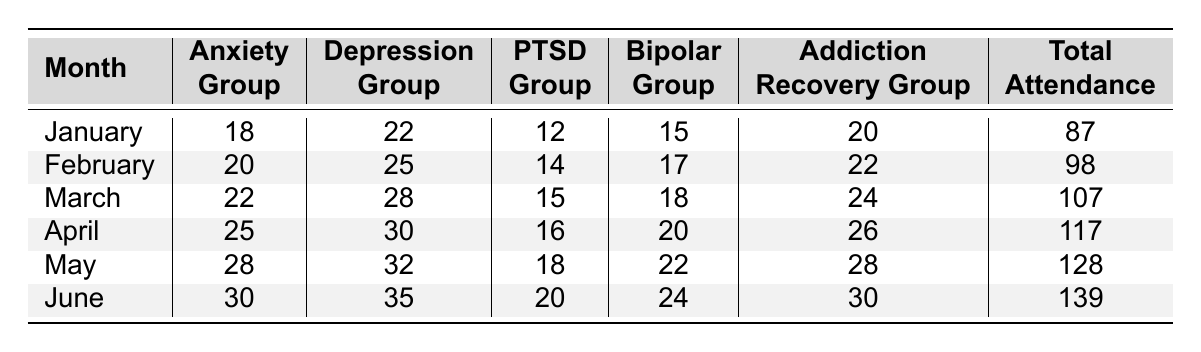What was the total attendance in March? The table shows that the total attendance for March is listed directly in the row for that month. It states that the total attendance is 107.
Answer: 107 Which group had the highest attendance in June? The June row lists attendance for all groups, with the Addiction Recovery Group having the highest attendance of 30.
Answer: Addiction Recovery Group What is the average attendance for the Anxiety Group over the six months? To find the average, sum the attendance for the Anxiety Group over the six months: 18 + 20 + 22 + 25 + 28 + 30 = 143. Divide by 6 to find the average: 143 / 6 ≈ 23.83.
Answer: Approximately 23.83 Did the total attendance increase every month from January to June? By comparing the Total Attendance values from January (87) to June (139), it can be seen that each month's total is higher than the previous month. Therefore, the attendance increased every month.
Answer: Yes What was the difference in attendance between the Depression Group in February and May? The attendance for the Depression Group in February is 25, and in May it is 32. The difference is calculated as 32 - 25 = 7.
Answer: 7 Which month had the largest total attendance? By reviewing the Total Attendance column for all months, June shows the highest value at 139.
Answer: June How many attendees were in the PTSD Group in April? The table shows that April has 16 attendees in the PTSD Group listed directly in that month's row.
Answer: 16 What is the total attendance of the Bipolar Group over the six months? For the Bipolar Group, the attendance figures for each month are: January (15), February (17), March (18), April (20), May (22), and June (24). The total is calculated as 15 + 17 + 18 + 20 + 22 + 24 = 116.
Answer: 116 How does the attendance of the Addiction Recovery Group in June compare to January? For January, the Addiction Recovery Group had 20 attendees, while in June it had 30. The difference is 30 - 20 = 10, indicating an increase.
Answer: Increased by 10 What percentage increase in total attendance occurred from January to June? The total attendance went from 87 in January to 139 in June. The increase is 139 - 87 = 52. To calculate the percentage increase: (52 / 87) * 100 ≈ 59.77%.
Answer: Approximately 59.77% 